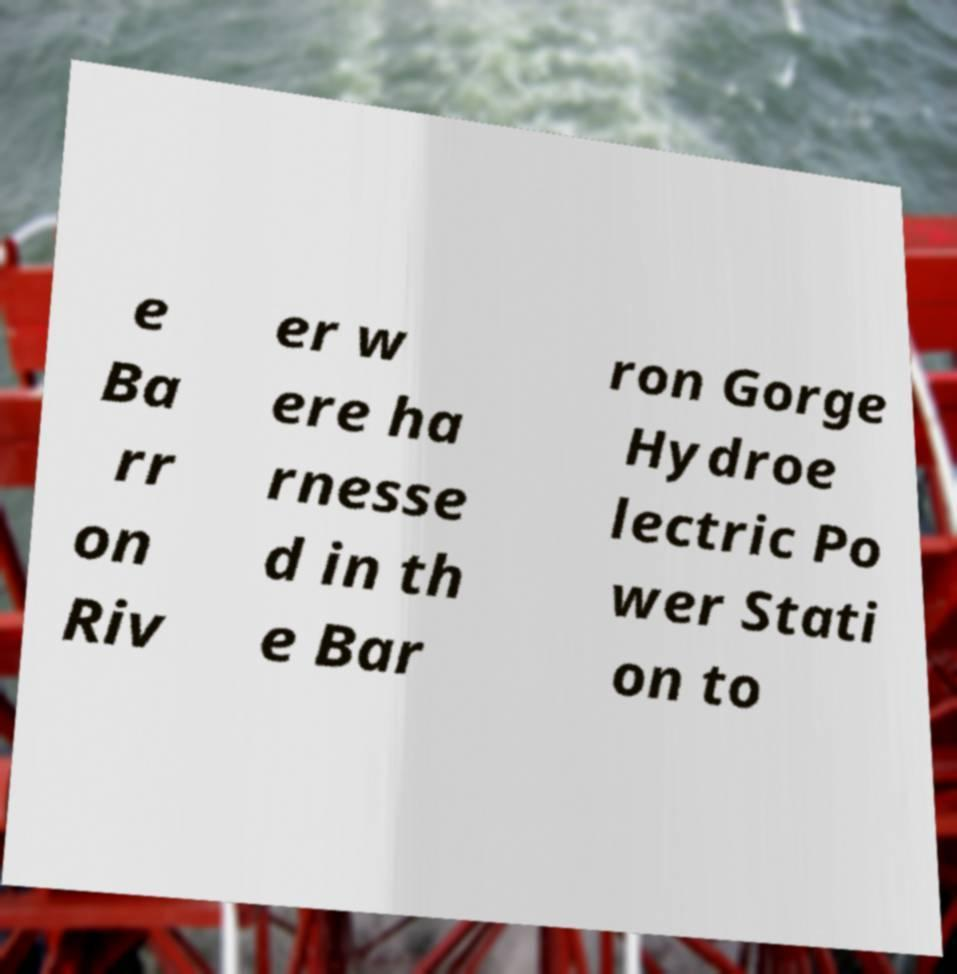For documentation purposes, I need the text within this image transcribed. Could you provide that? e Ba rr on Riv er w ere ha rnesse d in th e Bar ron Gorge Hydroe lectric Po wer Stati on to 